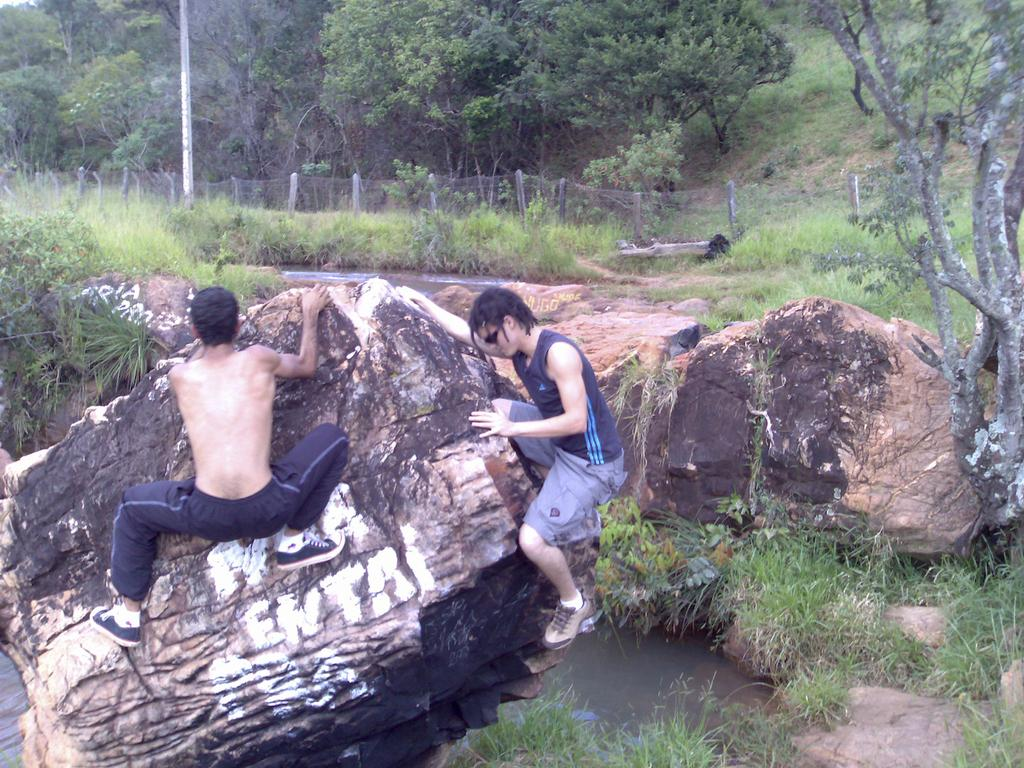How many people are in the image? There are two people in the image. What are the two people holding in the image? The two people are holding a rock in the image. What type of natural environment is visible in the image? There is water, green grass, trees, and fencing visible in the image. What is the pole used for in the image? The purpose of the pole in the image is not specified, but it could be used for support or as a marker. What type of skin condition can be seen on the rock in the image? There is no skin condition present on the rock in the image, as rocks do not have skin. How does the zipper on the rock work in the image? There is no zipper present on the rock in the image, as rocks do not have zippers. 